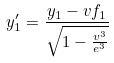Convert formula to latex. <formula><loc_0><loc_0><loc_500><loc_500>y _ { 1 } ^ { \prime } = \frac { y _ { 1 } - v f _ { 1 } } { \sqrt { 1 - \frac { v ^ { 3 } } { e ^ { 3 } } } }</formula> 